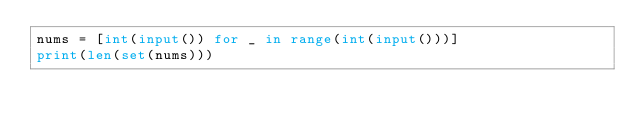<code> <loc_0><loc_0><loc_500><loc_500><_Python_>nums = [int(input()) for _ in range(int(input()))]
print(len(set(nums)))</code> 